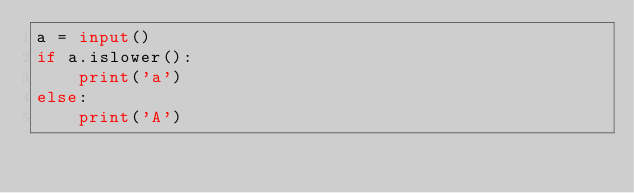<code> <loc_0><loc_0><loc_500><loc_500><_Python_>a = input()
if a.islower():
    print('a')
else:
    print('A')</code> 